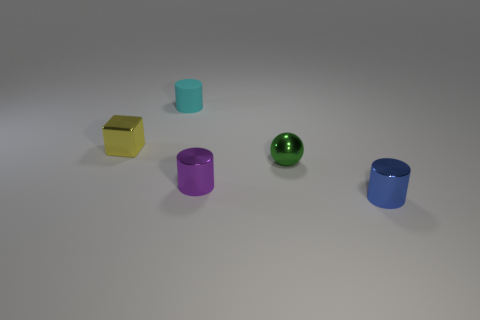What is the shape of the yellow thing that is the same size as the blue metallic cylinder?
Give a very brief answer. Cube. Are there any other small blue things that have the same shape as the tiny blue shiny object?
Make the answer very short. No. Do the object left of the small matte thing and the small cylinder that is behind the small yellow thing have the same material?
Ensure brevity in your answer.  No. What number of tiny purple things are made of the same material as the green object?
Your answer should be compact. 1. The small rubber thing has what color?
Provide a short and direct response. Cyan. Is the shape of the thing that is left of the cyan thing the same as the tiny shiny object on the right side of the small green thing?
Provide a short and direct response. No. There is a tiny object that is to the left of the cyan cylinder; what is its color?
Your answer should be very brief. Yellow. Is the number of small yellow shiny things that are to the right of the small yellow block less than the number of small cyan matte cylinders that are right of the cyan matte cylinder?
Offer a terse response. No. What number of other objects are the same material as the purple cylinder?
Offer a terse response. 3. Is the small ball made of the same material as the yellow object?
Provide a succinct answer. Yes. 